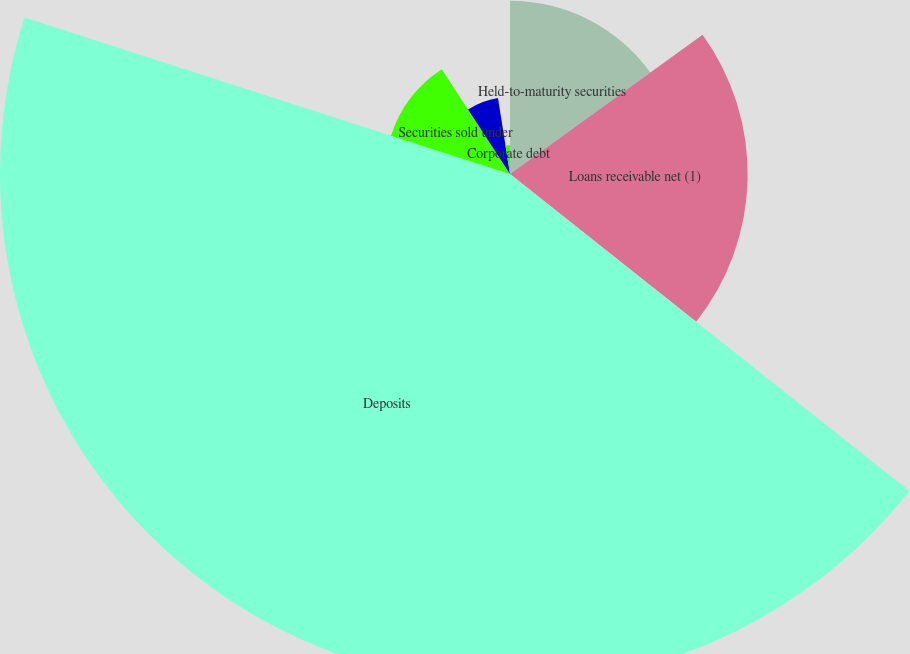Convert chart to OTSL. <chart><loc_0><loc_0><loc_500><loc_500><pie_chart><fcel>Held-to-maturity securities<fcel>Loans receivable net (1)<fcel>Deposits<fcel>Securities sold under<fcel>FHLB advances and other<fcel>Corporate debt<nl><fcel>15.04%<fcel>20.64%<fcel>44.29%<fcel>10.86%<fcel>6.68%<fcel>2.5%<nl></chart> 